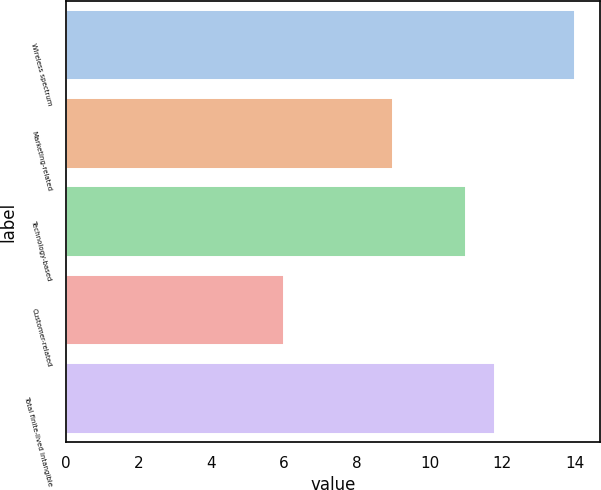Convert chart. <chart><loc_0><loc_0><loc_500><loc_500><bar_chart><fcel>Wireless spectrum<fcel>Marketing-related<fcel>Technology-based<fcel>Customer-related<fcel>Total finite-lived intangible<nl><fcel>14<fcel>9<fcel>11<fcel>6<fcel>11.8<nl></chart> 